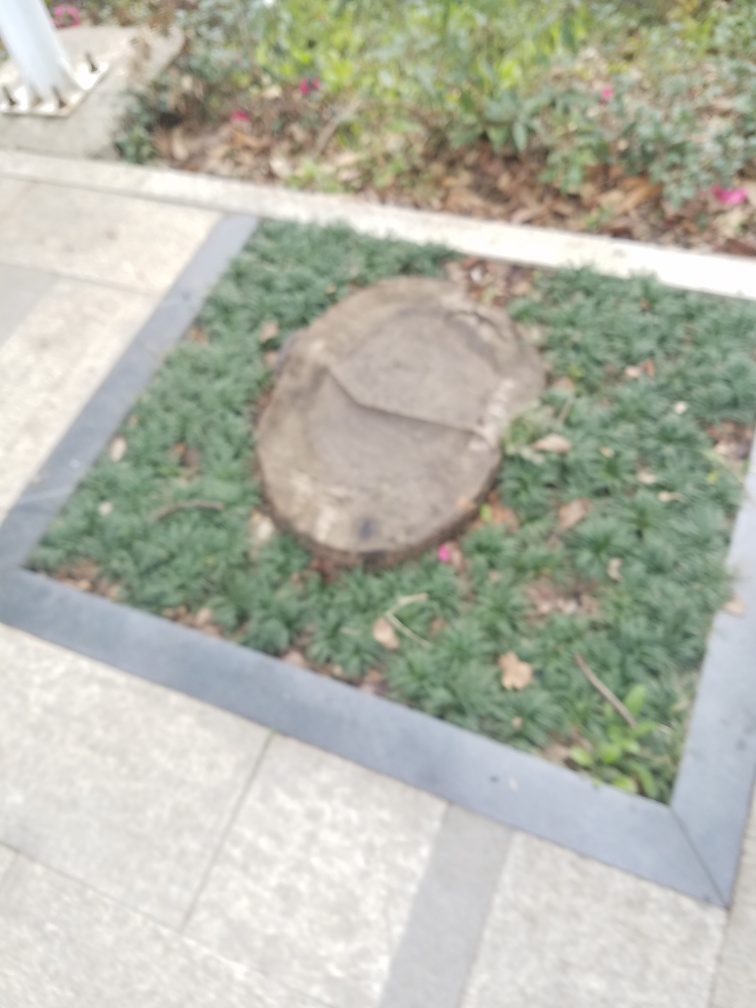Is the lighting bright? It appears to be daylight, as the natural light in the image suggests that the photo was taken during the day. However, the exact brightness levels are difficult to assess due to the image being somewhat out of focus. 